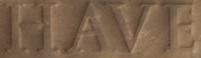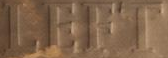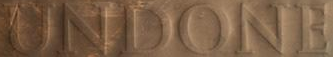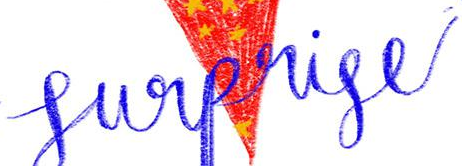What text is displayed in these images sequentially, separated by a semicolon? HAVE; LEFT; UNDONE; Surprise 